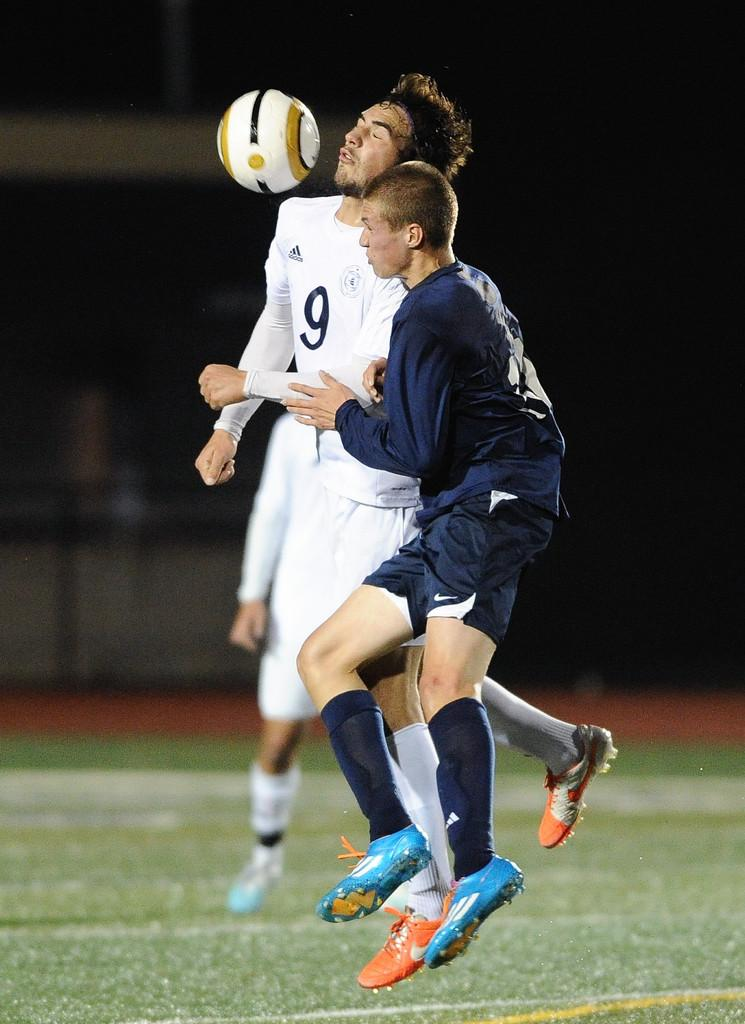Provide a one-sentence caption for the provided image. The number 9 soccer player in a white adidas jersey is crashing into another player while heading a ball. 